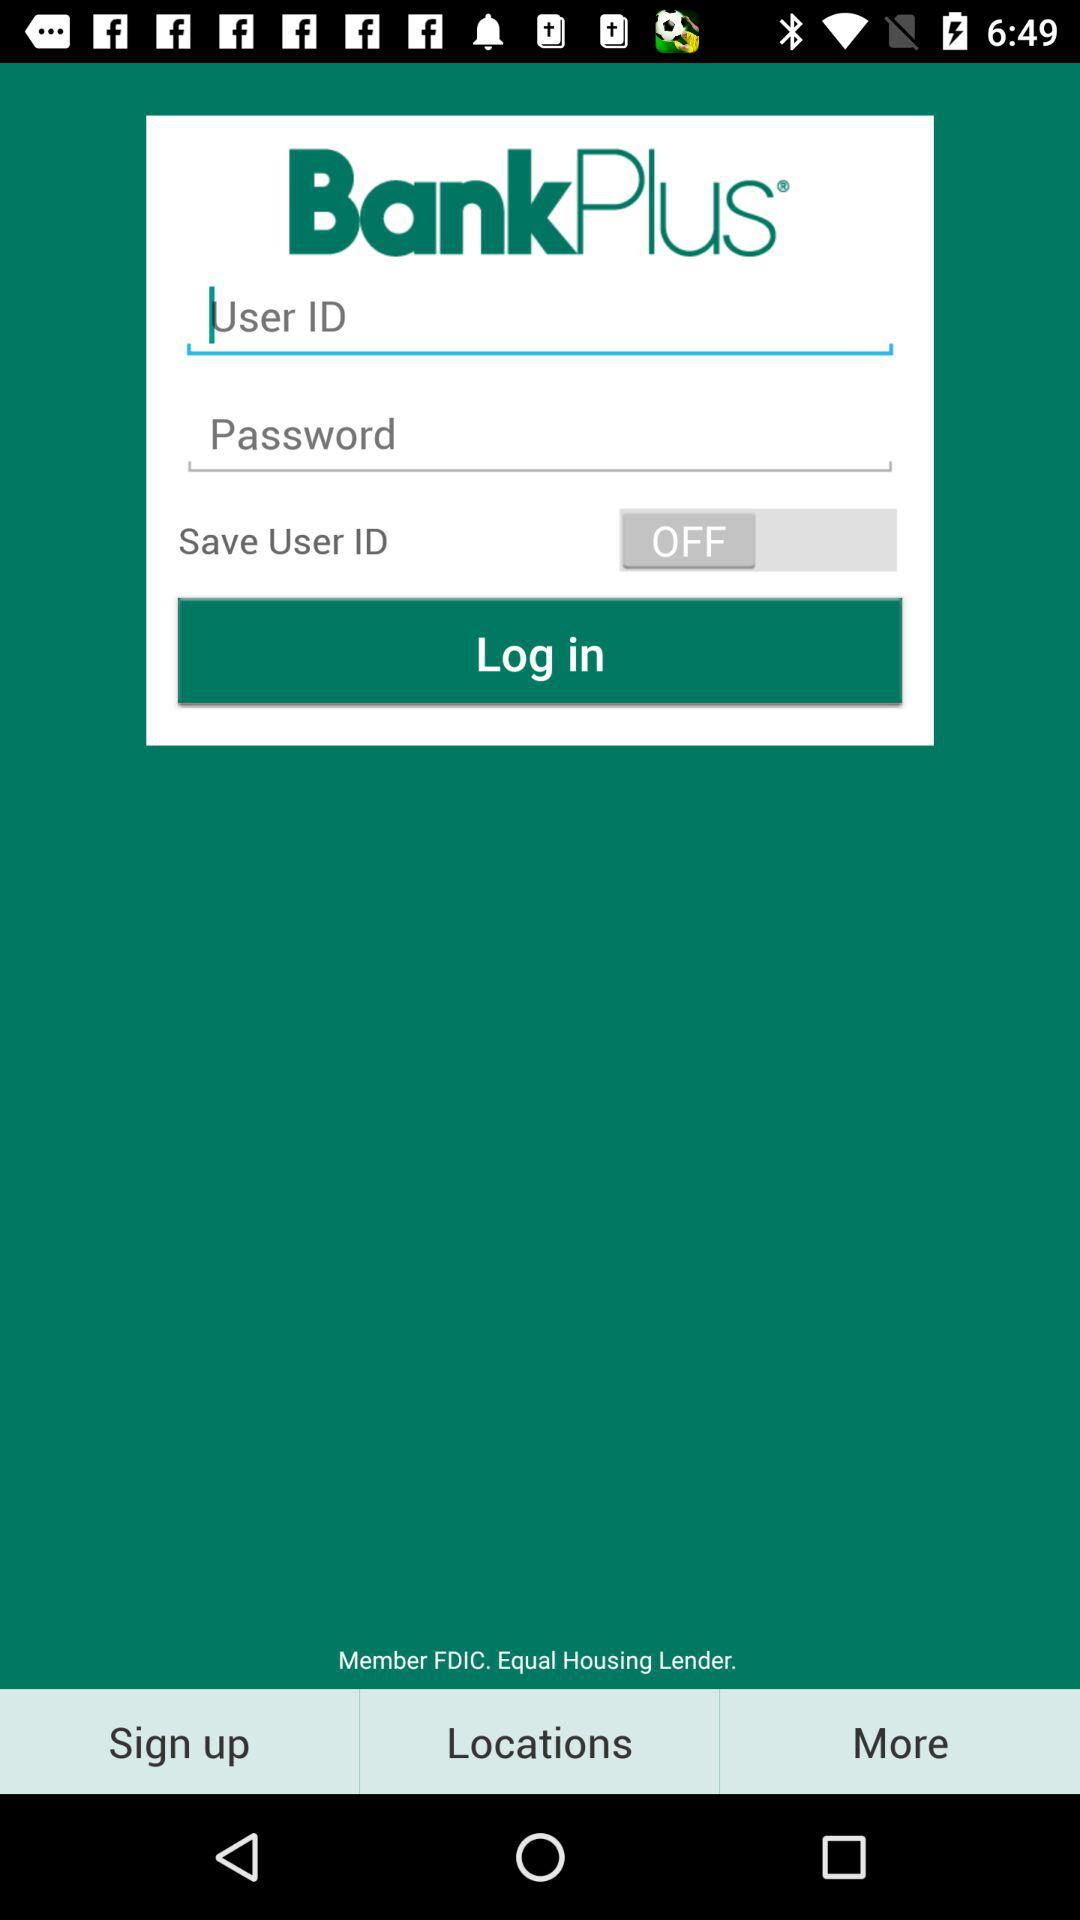What is the status of Save User ID? The status is off. 